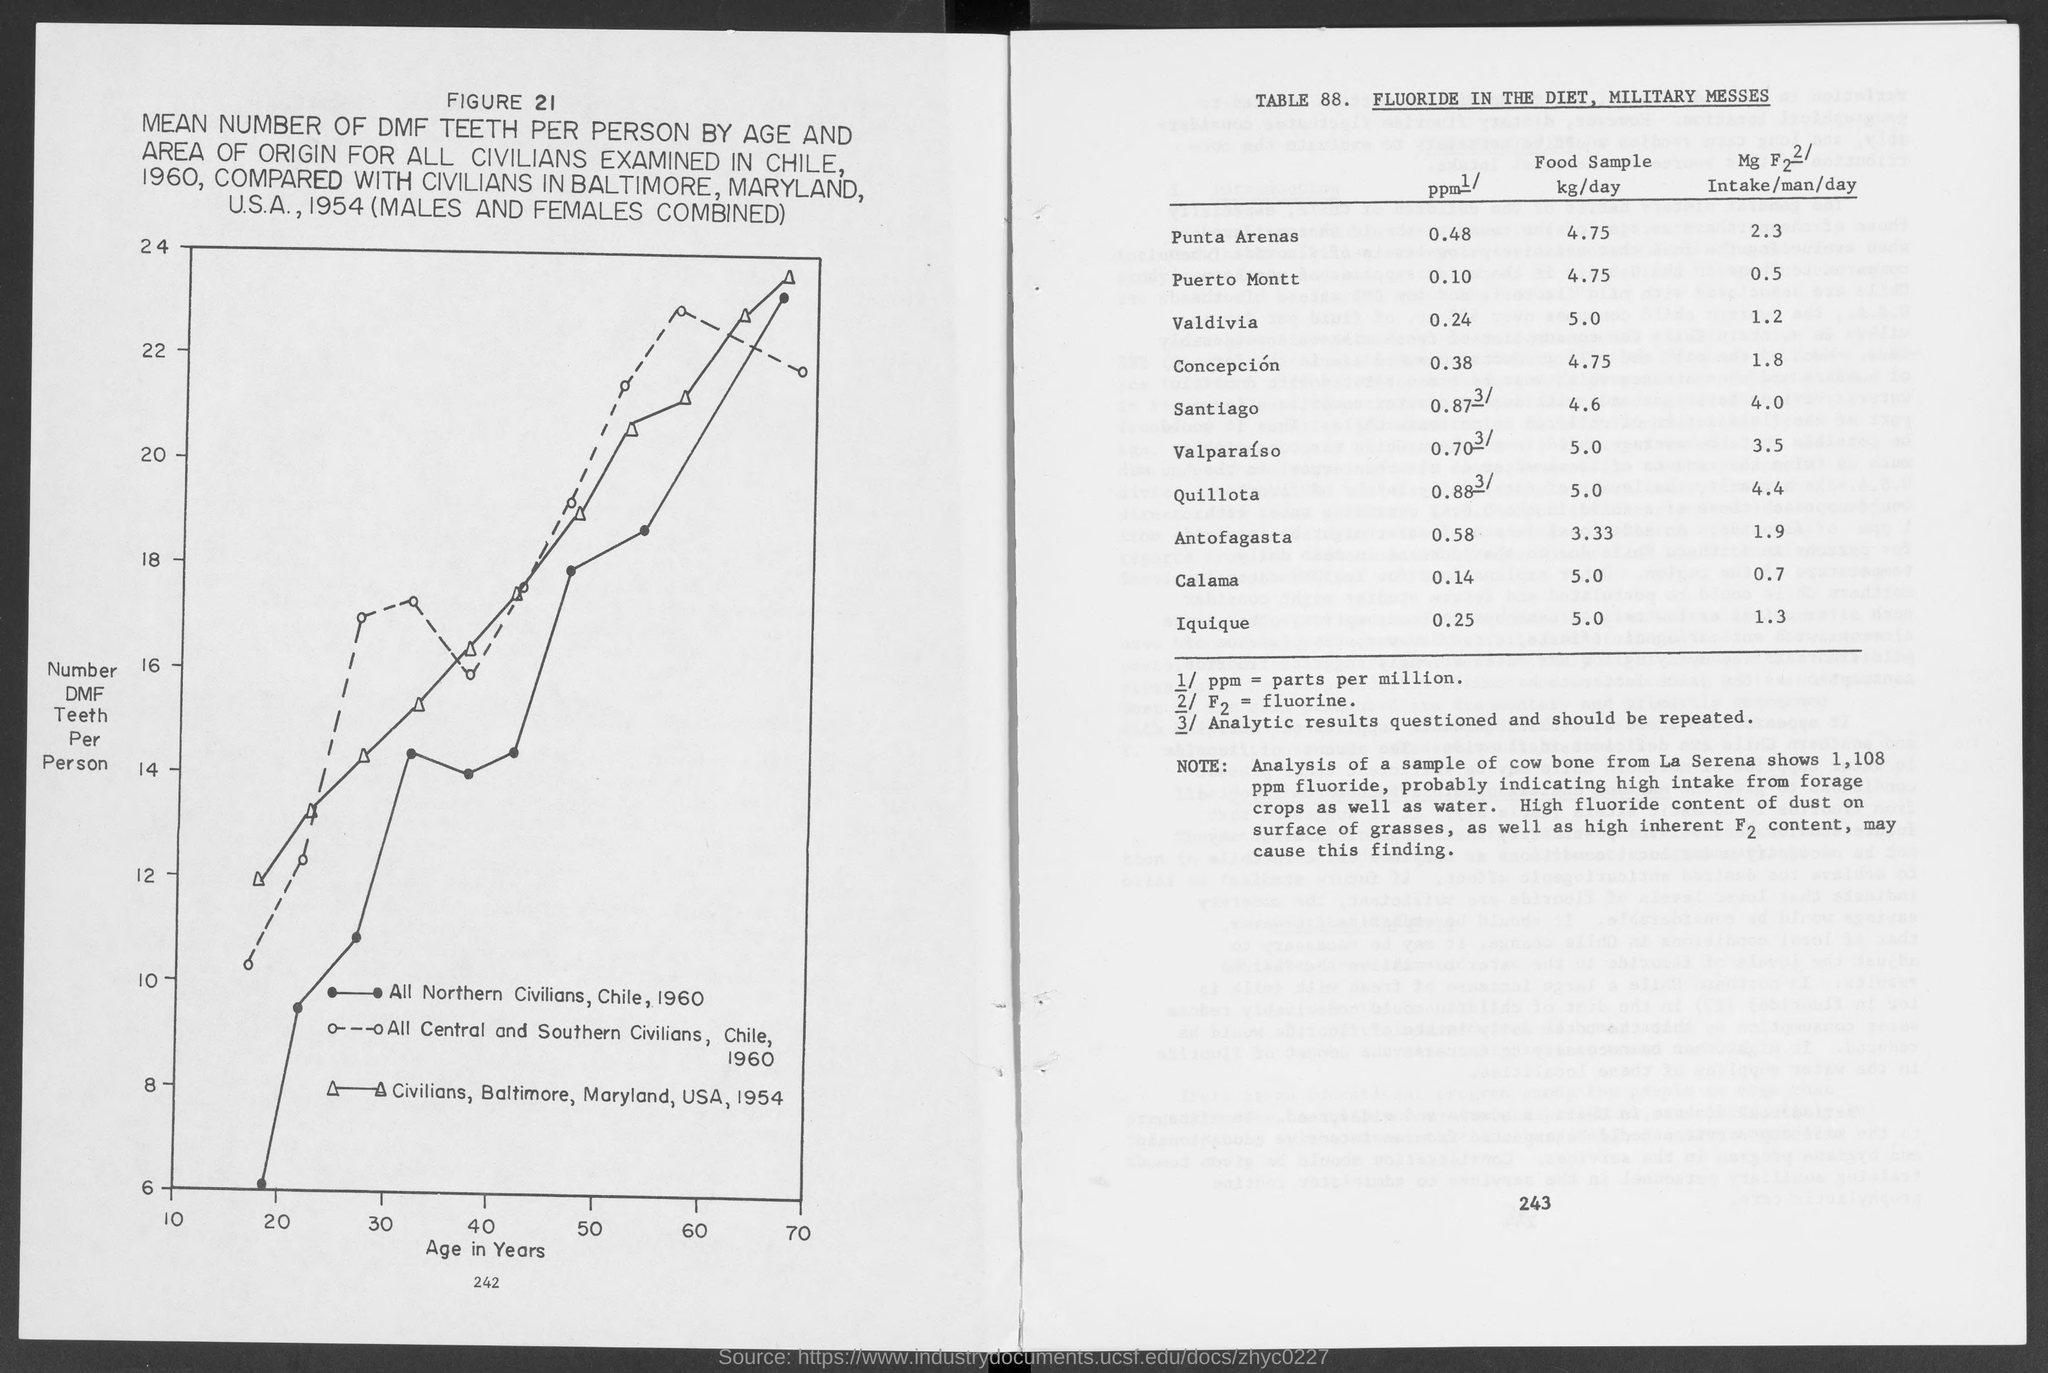What is the variable on X axis of the graph in FIGURE 21?
Your answer should be compact. Age in Years. What is the variable on Y axis of the graph in FIGURE 21?
Give a very brief answer. Number DMF Teeth Per Person. How much food sample was analysed in Valdivia in kg/day?
Provide a succinct answer. 5.0. What does ppm stand for?
Provide a succinct answer. Parts per million. How much fluoride did a sample of cow bone from La Serena show?
Give a very brief answer. 1,108 ppm fluoride. 